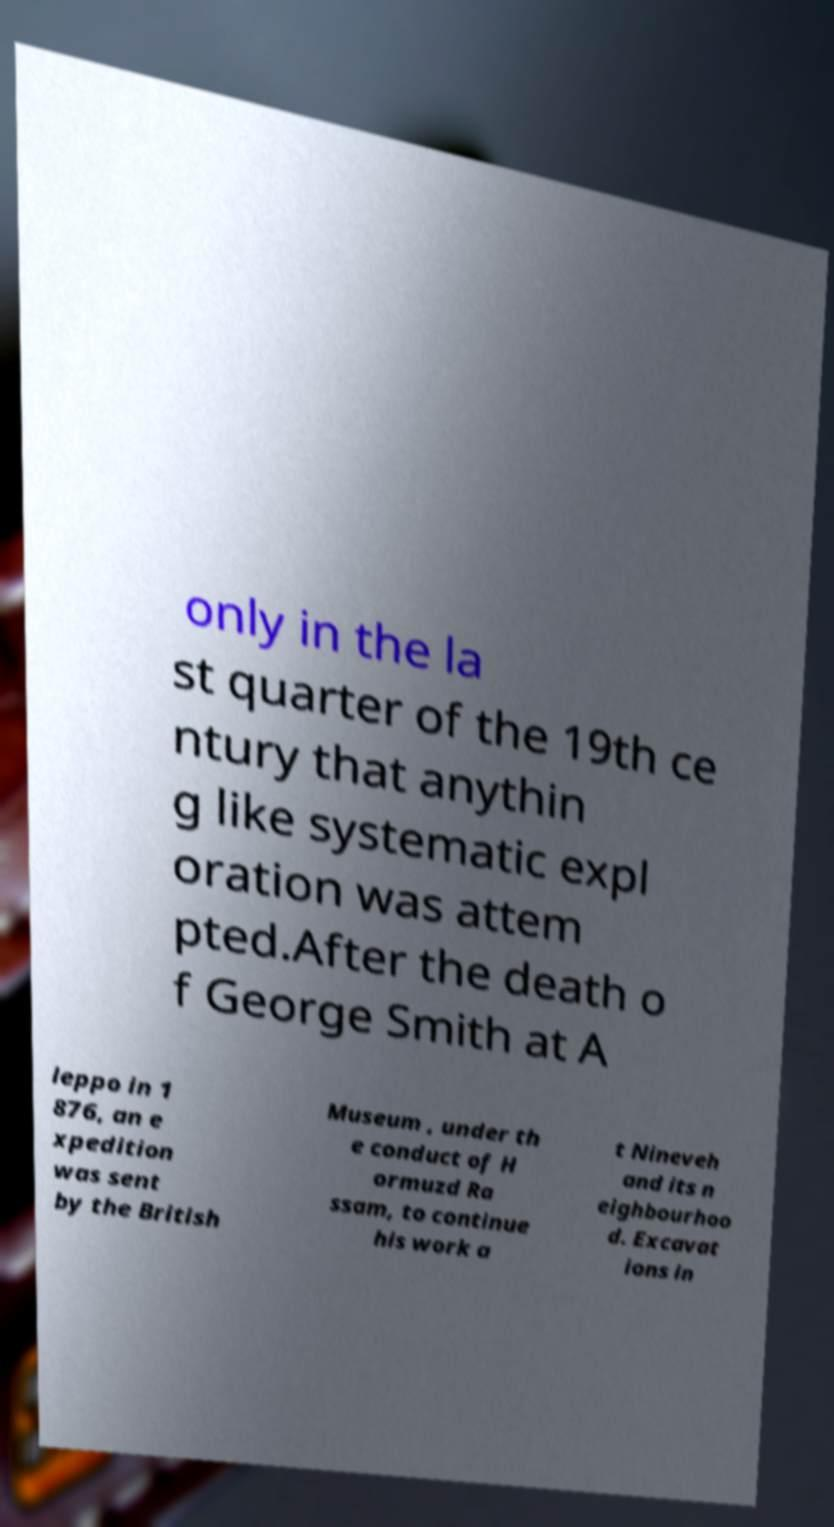I need the written content from this picture converted into text. Can you do that? only in the la st quarter of the 19th ce ntury that anythin g like systematic expl oration was attem pted.After the death o f George Smith at A leppo in 1 876, an e xpedition was sent by the British Museum , under th e conduct of H ormuzd Ra ssam, to continue his work a t Nineveh and its n eighbourhoo d. Excavat ions in 